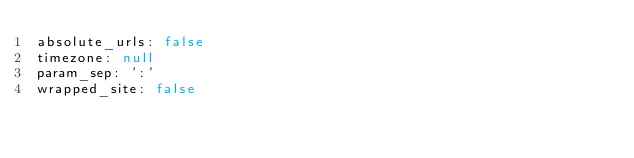Convert code to text. <code><loc_0><loc_0><loc_500><loc_500><_YAML_>absolute_urls: false
timezone: null
param_sep: ':'
wrapped_site: false</code> 